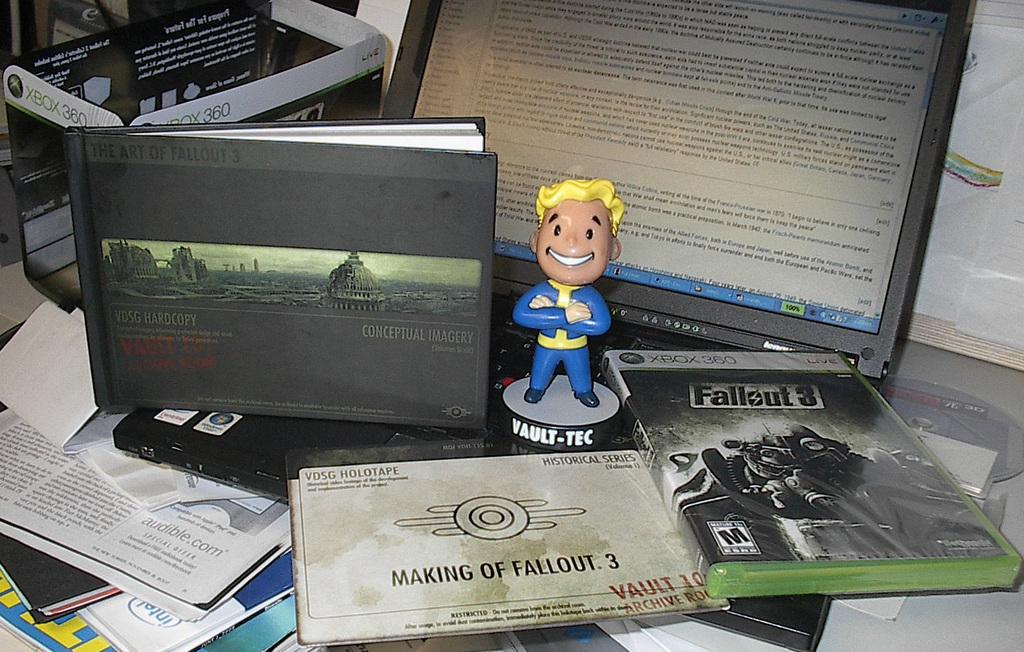What is the title of the video game?
Offer a very short reply. Fallout 3. What is the booklet about laying flat next to the video game?
Give a very brief answer. Making of fallout 3. 